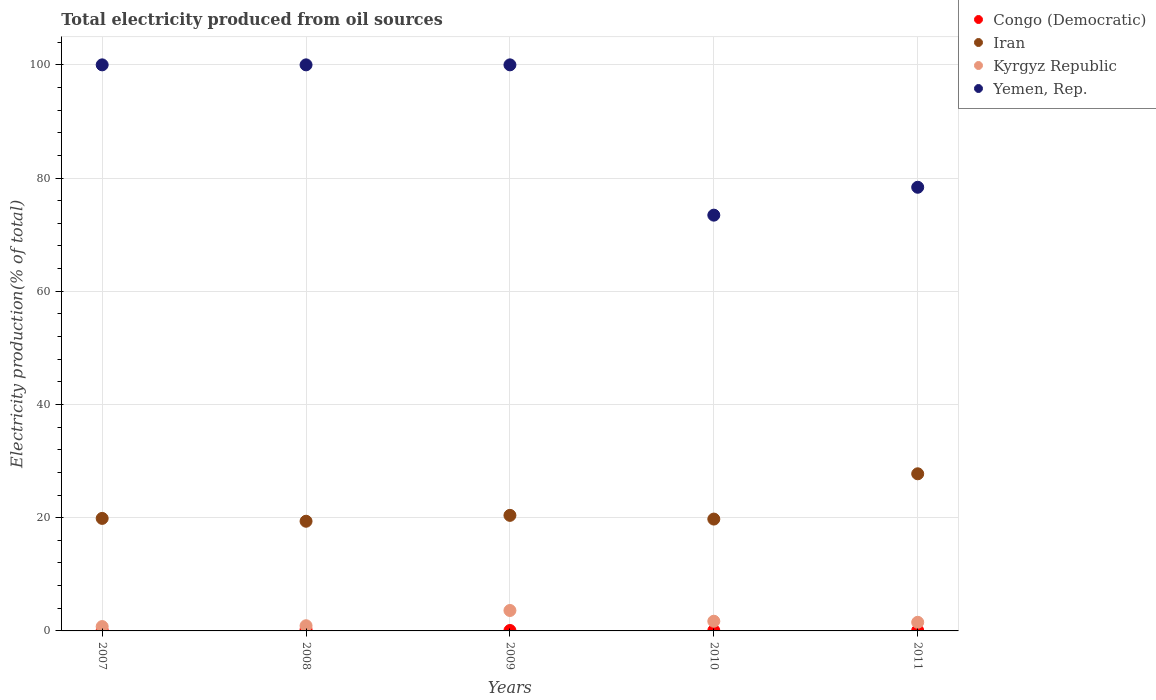Is the number of dotlines equal to the number of legend labels?
Provide a short and direct response. Yes. What is the total electricity produced in Yemen, Rep. in 2008?
Provide a short and direct response. 100. Across all years, what is the maximum total electricity produced in Yemen, Rep.?
Provide a short and direct response. 100. Across all years, what is the minimum total electricity produced in Kyrgyz Republic?
Provide a succinct answer. 0.77. What is the total total electricity produced in Iran in the graph?
Your answer should be very brief. 107.18. What is the difference between the total electricity produced in Yemen, Rep. in 2008 and that in 2011?
Offer a very short reply. 21.62. What is the difference between the total electricity produced in Kyrgyz Republic in 2007 and the total electricity produced in Iran in 2010?
Make the answer very short. -18.99. What is the average total electricity produced in Congo (Democratic) per year?
Give a very brief answer. 0.11. In the year 2011, what is the difference between the total electricity produced in Kyrgyz Republic and total electricity produced in Congo (Democratic)?
Ensure brevity in your answer.  1.45. What is the ratio of the total electricity produced in Yemen, Rep. in 2008 to that in 2010?
Keep it short and to the point. 1.36. What is the difference between the highest and the second highest total electricity produced in Kyrgyz Republic?
Provide a short and direct response. 1.9. What is the difference between the highest and the lowest total electricity produced in Kyrgyz Republic?
Offer a terse response. 2.84. Is the sum of the total electricity produced in Congo (Democratic) in 2008 and 2011 greater than the maximum total electricity produced in Iran across all years?
Your response must be concise. No. Is it the case that in every year, the sum of the total electricity produced in Kyrgyz Republic and total electricity produced in Congo (Democratic)  is greater than the sum of total electricity produced in Iran and total electricity produced in Yemen, Rep.?
Offer a terse response. Yes. Is it the case that in every year, the sum of the total electricity produced in Kyrgyz Republic and total electricity produced in Yemen, Rep.  is greater than the total electricity produced in Congo (Democratic)?
Make the answer very short. Yes. Does the total electricity produced in Iran monotonically increase over the years?
Make the answer very short. No. Is the total electricity produced in Yemen, Rep. strictly greater than the total electricity produced in Kyrgyz Republic over the years?
Ensure brevity in your answer.  Yes. Is the total electricity produced in Yemen, Rep. strictly less than the total electricity produced in Iran over the years?
Provide a short and direct response. No. How many dotlines are there?
Offer a very short reply. 4. How many years are there in the graph?
Your answer should be compact. 5. Does the graph contain any zero values?
Provide a succinct answer. No. Does the graph contain grids?
Keep it short and to the point. Yes. How are the legend labels stacked?
Your answer should be compact. Vertical. What is the title of the graph?
Provide a short and direct response. Total electricity produced from oil sources. Does "Middle East & North Africa (developing only)" appear as one of the legend labels in the graph?
Provide a succinct answer. No. What is the label or title of the X-axis?
Offer a terse response. Years. What is the Electricity production(% of total) of Congo (Democratic) in 2007?
Ensure brevity in your answer.  0.09. What is the Electricity production(% of total) in Iran in 2007?
Provide a short and direct response. 19.88. What is the Electricity production(% of total) in Kyrgyz Republic in 2007?
Your answer should be compact. 0.77. What is the Electricity production(% of total) in Congo (Democratic) in 2008?
Your answer should be very brief. 0.23. What is the Electricity production(% of total) of Iran in 2008?
Your answer should be very brief. 19.37. What is the Electricity production(% of total) of Kyrgyz Republic in 2008?
Your answer should be compact. 0.92. What is the Electricity production(% of total) in Congo (Democratic) in 2009?
Provide a short and direct response. 0.08. What is the Electricity production(% of total) of Iran in 2009?
Provide a succinct answer. 20.41. What is the Electricity production(% of total) in Kyrgyz Republic in 2009?
Your response must be concise. 3.61. What is the Electricity production(% of total) in Yemen, Rep. in 2009?
Your response must be concise. 100. What is the Electricity production(% of total) in Congo (Democratic) in 2010?
Make the answer very short. 0.08. What is the Electricity production(% of total) in Iran in 2010?
Offer a very short reply. 19.76. What is the Electricity production(% of total) of Kyrgyz Republic in 2010?
Your answer should be compact. 1.71. What is the Electricity production(% of total) of Yemen, Rep. in 2010?
Make the answer very short. 73.45. What is the Electricity production(% of total) of Congo (Democratic) in 2011?
Your answer should be very brief. 0.08. What is the Electricity production(% of total) of Iran in 2011?
Provide a short and direct response. 27.76. What is the Electricity production(% of total) of Kyrgyz Republic in 2011?
Provide a short and direct response. 1.52. What is the Electricity production(% of total) of Yemen, Rep. in 2011?
Offer a very short reply. 78.38. Across all years, what is the maximum Electricity production(% of total) in Congo (Democratic)?
Give a very brief answer. 0.23. Across all years, what is the maximum Electricity production(% of total) in Iran?
Keep it short and to the point. 27.76. Across all years, what is the maximum Electricity production(% of total) of Kyrgyz Republic?
Offer a terse response. 3.61. Across all years, what is the minimum Electricity production(% of total) in Congo (Democratic)?
Give a very brief answer. 0.08. Across all years, what is the minimum Electricity production(% of total) in Iran?
Provide a succinct answer. 19.37. Across all years, what is the minimum Electricity production(% of total) of Kyrgyz Republic?
Your answer should be compact. 0.77. Across all years, what is the minimum Electricity production(% of total) in Yemen, Rep.?
Make the answer very short. 73.45. What is the total Electricity production(% of total) in Congo (Democratic) in the graph?
Your answer should be compact. 0.54. What is the total Electricity production(% of total) of Iran in the graph?
Give a very brief answer. 107.18. What is the total Electricity production(% of total) of Kyrgyz Republic in the graph?
Ensure brevity in your answer.  8.53. What is the total Electricity production(% of total) in Yemen, Rep. in the graph?
Your response must be concise. 451.83. What is the difference between the Electricity production(% of total) in Congo (Democratic) in 2007 and that in 2008?
Ensure brevity in your answer.  -0.14. What is the difference between the Electricity production(% of total) in Iran in 2007 and that in 2008?
Offer a very short reply. 0.5. What is the difference between the Electricity production(% of total) of Kyrgyz Republic in 2007 and that in 2008?
Your response must be concise. -0.15. What is the difference between the Electricity production(% of total) of Congo (Democratic) in 2007 and that in 2009?
Provide a succinct answer. 0.01. What is the difference between the Electricity production(% of total) of Iran in 2007 and that in 2009?
Offer a terse response. -0.54. What is the difference between the Electricity production(% of total) in Kyrgyz Republic in 2007 and that in 2009?
Provide a short and direct response. -2.84. What is the difference between the Electricity production(% of total) in Congo (Democratic) in 2007 and that in 2010?
Your answer should be very brief. 0.01. What is the difference between the Electricity production(% of total) in Iran in 2007 and that in 2010?
Offer a very short reply. 0.12. What is the difference between the Electricity production(% of total) in Kyrgyz Republic in 2007 and that in 2010?
Give a very brief answer. -0.94. What is the difference between the Electricity production(% of total) of Yemen, Rep. in 2007 and that in 2010?
Your response must be concise. 26.55. What is the difference between the Electricity production(% of total) of Congo (Democratic) in 2007 and that in 2011?
Ensure brevity in your answer.  0.01. What is the difference between the Electricity production(% of total) of Iran in 2007 and that in 2011?
Make the answer very short. -7.88. What is the difference between the Electricity production(% of total) of Kyrgyz Republic in 2007 and that in 2011?
Keep it short and to the point. -0.76. What is the difference between the Electricity production(% of total) of Yemen, Rep. in 2007 and that in 2011?
Give a very brief answer. 21.62. What is the difference between the Electricity production(% of total) in Congo (Democratic) in 2008 and that in 2009?
Keep it short and to the point. 0.15. What is the difference between the Electricity production(% of total) of Iran in 2008 and that in 2009?
Give a very brief answer. -1.04. What is the difference between the Electricity production(% of total) of Kyrgyz Republic in 2008 and that in 2009?
Provide a succinct answer. -2.69. What is the difference between the Electricity production(% of total) in Congo (Democratic) in 2008 and that in 2010?
Your answer should be compact. 0.15. What is the difference between the Electricity production(% of total) of Iran in 2008 and that in 2010?
Offer a very short reply. -0.38. What is the difference between the Electricity production(% of total) of Kyrgyz Republic in 2008 and that in 2010?
Offer a terse response. -0.79. What is the difference between the Electricity production(% of total) of Yemen, Rep. in 2008 and that in 2010?
Make the answer very short. 26.55. What is the difference between the Electricity production(% of total) in Congo (Democratic) in 2008 and that in 2011?
Ensure brevity in your answer.  0.15. What is the difference between the Electricity production(% of total) in Iran in 2008 and that in 2011?
Provide a short and direct response. -8.38. What is the difference between the Electricity production(% of total) of Kyrgyz Republic in 2008 and that in 2011?
Your answer should be compact. -0.61. What is the difference between the Electricity production(% of total) of Yemen, Rep. in 2008 and that in 2011?
Give a very brief answer. 21.62. What is the difference between the Electricity production(% of total) of Iran in 2009 and that in 2010?
Offer a very short reply. 0.66. What is the difference between the Electricity production(% of total) of Kyrgyz Republic in 2009 and that in 2010?
Make the answer very short. 1.9. What is the difference between the Electricity production(% of total) of Yemen, Rep. in 2009 and that in 2010?
Give a very brief answer. 26.55. What is the difference between the Electricity production(% of total) in Iran in 2009 and that in 2011?
Give a very brief answer. -7.34. What is the difference between the Electricity production(% of total) in Kyrgyz Republic in 2009 and that in 2011?
Your answer should be compact. 2.09. What is the difference between the Electricity production(% of total) of Yemen, Rep. in 2009 and that in 2011?
Your response must be concise. 21.62. What is the difference between the Electricity production(% of total) in Congo (Democratic) in 2010 and that in 2011?
Provide a succinct answer. -0. What is the difference between the Electricity production(% of total) of Iran in 2010 and that in 2011?
Your answer should be compact. -8. What is the difference between the Electricity production(% of total) in Kyrgyz Republic in 2010 and that in 2011?
Make the answer very short. 0.19. What is the difference between the Electricity production(% of total) in Yemen, Rep. in 2010 and that in 2011?
Offer a very short reply. -4.93. What is the difference between the Electricity production(% of total) in Congo (Democratic) in 2007 and the Electricity production(% of total) in Iran in 2008?
Make the answer very short. -19.29. What is the difference between the Electricity production(% of total) in Congo (Democratic) in 2007 and the Electricity production(% of total) in Kyrgyz Republic in 2008?
Make the answer very short. -0.83. What is the difference between the Electricity production(% of total) of Congo (Democratic) in 2007 and the Electricity production(% of total) of Yemen, Rep. in 2008?
Ensure brevity in your answer.  -99.91. What is the difference between the Electricity production(% of total) in Iran in 2007 and the Electricity production(% of total) in Kyrgyz Republic in 2008?
Your response must be concise. 18.96. What is the difference between the Electricity production(% of total) in Iran in 2007 and the Electricity production(% of total) in Yemen, Rep. in 2008?
Ensure brevity in your answer.  -80.12. What is the difference between the Electricity production(% of total) of Kyrgyz Republic in 2007 and the Electricity production(% of total) of Yemen, Rep. in 2008?
Your answer should be compact. -99.23. What is the difference between the Electricity production(% of total) of Congo (Democratic) in 2007 and the Electricity production(% of total) of Iran in 2009?
Provide a short and direct response. -20.33. What is the difference between the Electricity production(% of total) of Congo (Democratic) in 2007 and the Electricity production(% of total) of Kyrgyz Republic in 2009?
Your answer should be compact. -3.52. What is the difference between the Electricity production(% of total) in Congo (Democratic) in 2007 and the Electricity production(% of total) in Yemen, Rep. in 2009?
Your answer should be compact. -99.91. What is the difference between the Electricity production(% of total) of Iran in 2007 and the Electricity production(% of total) of Kyrgyz Republic in 2009?
Provide a short and direct response. 16.27. What is the difference between the Electricity production(% of total) of Iran in 2007 and the Electricity production(% of total) of Yemen, Rep. in 2009?
Provide a succinct answer. -80.12. What is the difference between the Electricity production(% of total) in Kyrgyz Republic in 2007 and the Electricity production(% of total) in Yemen, Rep. in 2009?
Ensure brevity in your answer.  -99.23. What is the difference between the Electricity production(% of total) of Congo (Democratic) in 2007 and the Electricity production(% of total) of Iran in 2010?
Your answer should be compact. -19.67. What is the difference between the Electricity production(% of total) of Congo (Democratic) in 2007 and the Electricity production(% of total) of Kyrgyz Republic in 2010?
Ensure brevity in your answer.  -1.62. What is the difference between the Electricity production(% of total) in Congo (Democratic) in 2007 and the Electricity production(% of total) in Yemen, Rep. in 2010?
Your answer should be very brief. -73.36. What is the difference between the Electricity production(% of total) of Iran in 2007 and the Electricity production(% of total) of Kyrgyz Republic in 2010?
Provide a short and direct response. 18.17. What is the difference between the Electricity production(% of total) of Iran in 2007 and the Electricity production(% of total) of Yemen, Rep. in 2010?
Offer a terse response. -53.57. What is the difference between the Electricity production(% of total) of Kyrgyz Republic in 2007 and the Electricity production(% of total) of Yemen, Rep. in 2010?
Give a very brief answer. -72.68. What is the difference between the Electricity production(% of total) in Congo (Democratic) in 2007 and the Electricity production(% of total) in Iran in 2011?
Make the answer very short. -27.67. What is the difference between the Electricity production(% of total) of Congo (Democratic) in 2007 and the Electricity production(% of total) of Kyrgyz Republic in 2011?
Offer a terse response. -1.43. What is the difference between the Electricity production(% of total) of Congo (Democratic) in 2007 and the Electricity production(% of total) of Yemen, Rep. in 2011?
Your answer should be very brief. -78.29. What is the difference between the Electricity production(% of total) of Iran in 2007 and the Electricity production(% of total) of Kyrgyz Republic in 2011?
Offer a very short reply. 18.35. What is the difference between the Electricity production(% of total) in Iran in 2007 and the Electricity production(% of total) in Yemen, Rep. in 2011?
Provide a short and direct response. -58.5. What is the difference between the Electricity production(% of total) in Kyrgyz Republic in 2007 and the Electricity production(% of total) in Yemen, Rep. in 2011?
Provide a succinct answer. -77.61. What is the difference between the Electricity production(% of total) of Congo (Democratic) in 2008 and the Electricity production(% of total) of Iran in 2009?
Provide a succinct answer. -20.19. What is the difference between the Electricity production(% of total) in Congo (Democratic) in 2008 and the Electricity production(% of total) in Kyrgyz Republic in 2009?
Provide a succinct answer. -3.38. What is the difference between the Electricity production(% of total) in Congo (Democratic) in 2008 and the Electricity production(% of total) in Yemen, Rep. in 2009?
Offer a terse response. -99.77. What is the difference between the Electricity production(% of total) in Iran in 2008 and the Electricity production(% of total) in Kyrgyz Republic in 2009?
Provide a succinct answer. 15.77. What is the difference between the Electricity production(% of total) in Iran in 2008 and the Electricity production(% of total) in Yemen, Rep. in 2009?
Your answer should be very brief. -80.63. What is the difference between the Electricity production(% of total) of Kyrgyz Republic in 2008 and the Electricity production(% of total) of Yemen, Rep. in 2009?
Provide a succinct answer. -99.08. What is the difference between the Electricity production(% of total) in Congo (Democratic) in 2008 and the Electricity production(% of total) in Iran in 2010?
Your response must be concise. -19.53. What is the difference between the Electricity production(% of total) in Congo (Democratic) in 2008 and the Electricity production(% of total) in Kyrgyz Republic in 2010?
Offer a terse response. -1.49. What is the difference between the Electricity production(% of total) in Congo (Democratic) in 2008 and the Electricity production(% of total) in Yemen, Rep. in 2010?
Ensure brevity in your answer.  -73.22. What is the difference between the Electricity production(% of total) of Iran in 2008 and the Electricity production(% of total) of Kyrgyz Republic in 2010?
Your answer should be very brief. 17.66. What is the difference between the Electricity production(% of total) of Iran in 2008 and the Electricity production(% of total) of Yemen, Rep. in 2010?
Make the answer very short. -54.07. What is the difference between the Electricity production(% of total) in Kyrgyz Republic in 2008 and the Electricity production(% of total) in Yemen, Rep. in 2010?
Give a very brief answer. -72.53. What is the difference between the Electricity production(% of total) in Congo (Democratic) in 2008 and the Electricity production(% of total) in Iran in 2011?
Keep it short and to the point. -27.53. What is the difference between the Electricity production(% of total) in Congo (Democratic) in 2008 and the Electricity production(% of total) in Kyrgyz Republic in 2011?
Offer a terse response. -1.3. What is the difference between the Electricity production(% of total) of Congo (Democratic) in 2008 and the Electricity production(% of total) of Yemen, Rep. in 2011?
Provide a short and direct response. -78.15. What is the difference between the Electricity production(% of total) in Iran in 2008 and the Electricity production(% of total) in Kyrgyz Republic in 2011?
Ensure brevity in your answer.  17.85. What is the difference between the Electricity production(% of total) of Iran in 2008 and the Electricity production(% of total) of Yemen, Rep. in 2011?
Ensure brevity in your answer.  -59. What is the difference between the Electricity production(% of total) of Kyrgyz Republic in 2008 and the Electricity production(% of total) of Yemen, Rep. in 2011?
Give a very brief answer. -77.46. What is the difference between the Electricity production(% of total) in Congo (Democratic) in 2009 and the Electricity production(% of total) in Iran in 2010?
Your answer should be very brief. -19.68. What is the difference between the Electricity production(% of total) in Congo (Democratic) in 2009 and the Electricity production(% of total) in Kyrgyz Republic in 2010?
Your answer should be compact. -1.63. What is the difference between the Electricity production(% of total) in Congo (Democratic) in 2009 and the Electricity production(% of total) in Yemen, Rep. in 2010?
Your answer should be compact. -73.37. What is the difference between the Electricity production(% of total) in Iran in 2009 and the Electricity production(% of total) in Kyrgyz Republic in 2010?
Keep it short and to the point. 18.7. What is the difference between the Electricity production(% of total) in Iran in 2009 and the Electricity production(% of total) in Yemen, Rep. in 2010?
Your response must be concise. -53.04. What is the difference between the Electricity production(% of total) in Kyrgyz Republic in 2009 and the Electricity production(% of total) in Yemen, Rep. in 2010?
Your answer should be very brief. -69.84. What is the difference between the Electricity production(% of total) in Congo (Democratic) in 2009 and the Electricity production(% of total) in Iran in 2011?
Provide a succinct answer. -27.68. What is the difference between the Electricity production(% of total) of Congo (Democratic) in 2009 and the Electricity production(% of total) of Kyrgyz Republic in 2011?
Provide a succinct answer. -1.45. What is the difference between the Electricity production(% of total) of Congo (Democratic) in 2009 and the Electricity production(% of total) of Yemen, Rep. in 2011?
Provide a succinct answer. -78.3. What is the difference between the Electricity production(% of total) of Iran in 2009 and the Electricity production(% of total) of Kyrgyz Republic in 2011?
Provide a short and direct response. 18.89. What is the difference between the Electricity production(% of total) of Iran in 2009 and the Electricity production(% of total) of Yemen, Rep. in 2011?
Make the answer very short. -57.96. What is the difference between the Electricity production(% of total) of Kyrgyz Republic in 2009 and the Electricity production(% of total) of Yemen, Rep. in 2011?
Your answer should be compact. -74.77. What is the difference between the Electricity production(% of total) of Congo (Democratic) in 2010 and the Electricity production(% of total) of Iran in 2011?
Keep it short and to the point. -27.68. What is the difference between the Electricity production(% of total) in Congo (Democratic) in 2010 and the Electricity production(% of total) in Kyrgyz Republic in 2011?
Make the answer very short. -1.45. What is the difference between the Electricity production(% of total) of Congo (Democratic) in 2010 and the Electricity production(% of total) of Yemen, Rep. in 2011?
Your answer should be very brief. -78.3. What is the difference between the Electricity production(% of total) in Iran in 2010 and the Electricity production(% of total) in Kyrgyz Republic in 2011?
Offer a very short reply. 18.23. What is the difference between the Electricity production(% of total) of Iran in 2010 and the Electricity production(% of total) of Yemen, Rep. in 2011?
Provide a succinct answer. -58.62. What is the difference between the Electricity production(% of total) in Kyrgyz Republic in 2010 and the Electricity production(% of total) in Yemen, Rep. in 2011?
Your answer should be very brief. -76.67. What is the average Electricity production(% of total) of Congo (Democratic) per year?
Give a very brief answer. 0.11. What is the average Electricity production(% of total) of Iran per year?
Your response must be concise. 21.44. What is the average Electricity production(% of total) in Kyrgyz Republic per year?
Offer a terse response. 1.71. What is the average Electricity production(% of total) of Yemen, Rep. per year?
Provide a succinct answer. 90.36. In the year 2007, what is the difference between the Electricity production(% of total) in Congo (Democratic) and Electricity production(% of total) in Iran?
Provide a short and direct response. -19.79. In the year 2007, what is the difference between the Electricity production(% of total) in Congo (Democratic) and Electricity production(% of total) in Kyrgyz Republic?
Give a very brief answer. -0.68. In the year 2007, what is the difference between the Electricity production(% of total) in Congo (Democratic) and Electricity production(% of total) in Yemen, Rep.?
Provide a succinct answer. -99.91. In the year 2007, what is the difference between the Electricity production(% of total) of Iran and Electricity production(% of total) of Kyrgyz Republic?
Keep it short and to the point. 19.11. In the year 2007, what is the difference between the Electricity production(% of total) of Iran and Electricity production(% of total) of Yemen, Rep.?
Provide a short and direct response. -80.12. In the year 2007, what is the difference between the Electricity production(% of total) of Kyrgyz Republic and Electricity production(% of total) of Yemen, Rep.?
Give a very brief answer. -99.23. In the year 2008, what is the difference between the Electricity production(% of total) of Congo (Democratic) and Electricity production(% of total) of Iran?
Make the answer very short. -19.15. In the year 2008, what is the difference between the Electricity production(% of total) in Congo (Democratic) and Electricity production(% of total) in Kyrgyz Republic?
Provide a succinct answer. -0.69. In the year 2008, what is the difference between the Electricity production(% of total) of Congo (Democratic) and Electricity production(% of total) of Yemen, Rep.?
Give a very brief answer. -99.77. In the year 2008, what is the difference between the Electricity production(% of total) of Iran and Electricity production(% of total) of Kyrgyz Republic?
Your answer should be very brief. 18.46. In the year 2008, what is the difference between the Electricity production(% of total) of Iran and Electricity production(% of total) of Yemen, Rep.?
Your answer should be very brief. -80.63. In the year 2008, what is the difference between the Electricity production(% of total) of Kyrgyz Republic and Electricity production(% of total) of Yemen, Rep.?
Your answer should be compact. -99.08. In the year 2009, what is the difference between the Electricity production(% of total) of Congo (Democratic) and Electricity production(% of total) of Iran?
Offer a very short reply. -20.34. In the year 2009, what is the difference between the Electricity production(% of total) in Congo (Democratic) and Electricity production(% of total) in Kyrgyz Republic?
Provide a short and direct response. -3.53. In the year 2009, what is the difference between the Electricity production(% of total) of Congo (Democratic) and Electricity production(% of total) of Yemen, Rep.?
Your response must be concise. -99.92. In the year 2009, what is the difference between the Electricity production(% of total) in Iran and Electricity production(% of total) in Kyrgyz Republic?
Keep it short and to the point. 16.81. In the year 2009, what is the difference between the Electricity production(% of total) in Iran and Electricity production(% of total) in Yemen, Rep.?
Your answer should be very brief. -79.59. In the year 2009, what is the difference between the Electricity production(% of total) in Kyrgyz Republic and Electricity production(% of total) in Yemen, Rep.?
Provide a short and direct response. -96.39. In the year 2010, what is the difference between the Electricity production(% of total) of Congo (Democratic) and Electricity production(% of total) of Iran?
Your answer should be compact. -19.68. In the year 2010, what is the difference between the Electricity production(% of total) in Congo (Democratic) and Electricity production(% of total) in Kyrgyz Republic?
Provide a short and direct response. -1.63. In the year 2010, what is the difference between the Electricity production(% of total) of Congo (Democratic) and Electricity production(% of total) of Yemen, Rep.?
Offer a very short reply. -73.37. In the year 2010, what is the difference between the Electricity production(% of total) in Iran and Electricity production(% of total) in Kyrgyz Republic?
Ensure brevity in your answer.  18.05. In the year 2010, what is the difference between the Electricity production(% of total) in Iran and Electricity production(% of total) in Yemen, Rep.?
Provide a succinct answer. -53.69. In the year 2010, what is the difference between the Electricity production(% of total) in Kyrgyz Republic and Electricity production(% of total) in Yemen, Rep.?
Your answer should be very brief. -71.74. In the year 2011, what is the difference between the Electricity production(% of total) of Congo (Democratic) and Electricity production(% of total) of Iran?
Your answer should be compact. -27.68. In the year 2011, what is the difference between the Electricity production(% of total) of Congo (Democratic) and Electricity production(% of total) of Kyrgyz Republic?
Keep it short and to the point. -1.45. In the year 2011, what is the difference between the Electricity production(% of total) in Congo (Democratic) and Electricity production(% of total) in Yemen, Rep.?
Provide a short and direct response. -78.3. In the year 2011, what is the difference between the Electricity production(% of total) in Iran and Electricity production(% of total) in Kyrgyz Republic?
Offer a very short reply. 26.23. In the year 2011, what is the difference between the Electricity production(% of total) of Iran and Electricity production(% of total) of Yemen, Rep.?
Your response must be concise. -50.62. In the year 2011, what is the difference between the Electricity production(% of total) of Kyrgyz Republic and Electricity production(% of total) of Yemen, Rep.?
Give a very brief answer. -76.85. What is the ratio of the Electricity production(% of total) in Congo (Democratic) in 2007 to that in 2008?
Give a very brief answer. 0.39. What is the ratio of the Electricity production(% of total) in Iran in 2007 to that in 2008?
Make the answer very short. 1.03. What is the ratio of the Electricity production(% of total) in Kyrgyz Republic in 2007 to that in 2008?
Offer a terse response. 0.84. What is the ratio of the Electricity production(% of total) of Yemen, Rep. in 2007 to that in 2008?
Make the answer very short. 1. What is the ratio of the Electricity production(% of total) in Congo (Democratic) in 2007 to that in 2009?
Your answer should be compact. 1.16. What is the ratio of the Electricity production(% of total) in Iran in 2007 to that in 2009?
Offer a terse response. 0.97. What is the ratio of the Electricity production(% of total) in Kyrgyz Republic in 2007 to that in 2009?
Provide a succinct answer. 0.21. What is the ratio of the Electricity production(% of total) of Congo (Democratic) in 2007 to that in 2010?
Make the answer very short. 1.17. What is the ratio of the Electricity production(% of total) in Iran in 2007 to that in 2010?
Ensure brevity in your answer.  1.01. What is the ratio of the Electricity production(% of total) in Kyrgyz Republic in 2007 to that in 2010?
Your answer should be very brief. 0.45. What is the ratio of the Electricity production(% of total) of Yemen, Rep. in 2007 to that in 2010?
Provide a short and direct response. 1.36. What is the ratio of the Electricity production(% of total) of Congo (Democratic) in 2007 to that in 2011?
Your answer should be very brief. 1.17. What is the ratio of the Electricity production(% of total) of Iran in 2007 to that in 2011?
Your answer should be very brief. 0.72. What is the ratio of the Electricity production(% of total) of Kyrgyz Republic in 2007 to that in 2011?
Keep it short and to the point. 0.5. What is the ratio of the Electricity production(% of total) of Yemen, Rep. in 2007 to that in 2011?
Your answer should be very brief. 1.28. What is the ratio of the Electricity production(% of total) in Congo (Democratic) in 2008 to that in 2009?
Make the answer very short. 2.95. What is the ratio of the Electricity production(% of total) of Iran in 2008 to that in 2009?
Give a very brief answer. 0.95. What is the ratio of the Electricity production(% of total) of Kyrgyz Republic in 2008 to that in 2009?
Your response must be concise. 0.25. What is the ratio of the Electricity production(% of total) in Yemen, Rep. in 2008 to that in 2009?
Your answer should be very brief. 1. What is the ratio of the Electricity production(% of total) of Congo (Democratic) in 2008 to that in 2010?
Make the answer very short. 2.97. What is the ratio of the Electricity production(% of total) in Iran in 2008 to that in 2010?
Offer a very short reply. 0.98. What is the ratio of the Electricity production(% of total) in Kyrgyz Republic in 2008 to that in 2010?
Give a very brief answer. 0.54. What is the ratio of the Electricity production(% of total) of Yemen, Rep. in 2008 to that in 2010?
Offer a terse response. 1.36. What is the ratio of the Electricity production(% of total) of Congo (Democratic) in 2008 to that in 2011?
Ensure brevity in your answer.  2.97. What is the ratio of the Electricity production(% of total) in Iran in 2008 to that in 2011?
Give a very brief answer. 0.7. What is the ratio of the Electricity production(% of total) in Kyrgyz Republic in 2008 to that in 2011?
Make the answer very short. 0.6. What is the ratio of the Electricity production(% of total) in Yemen, Rep. in 2008 to that in 2011?
Offer a very short reply. 1.28. What is the ratio of the Electricity production(% of total) of Congo (Democratic) in 2009 to that in 2010?
Give a very brief answer. 1.01. What is the ratio of the Electricity production(% of total) in Iran in 2009 to that in 2010?
Give a very brief answer. 1.03. What is the ratio of the Electricity production(% of total) in Kyrgyz Republic in 2009 to that in 2010?
Ensure brevity in your answer.  2.11. What is the ratio of the Electricity production(% of total) in Yemen, Rep. in 2009 to that in 2010?
Your answer should be compact. 1.36. What is the ratio of the Electricity production(% of total) of Iran in 2009 to that in 2011?
Offer a very short reply. 0.74. What is the ratio of the Electricity production(% of total) in Kyrgyz Republic in 2009 to that in 2011?
Provide a short and direct response. 2.37. What is the ratio of the Electricity production(% of total) of Yemen, Rep. in 2009 to that in 2011?
Ensure brevity in your answer.  1.28. What is the ratio of the Electricity production(% of total) of Iran in 2010 to that in 2011?
Keep it short and to the point. 0.71. What is the ratio of the Electricity production(% of total) in Kyrgyz Republic in 2010 to that in 2011?
Your response must be concise. 1.12. What is the ratio of the Electricity production(% of total) of Yemen, Rep. in 2010 to that in 2011?
Make the answer very short. 0.94. What is the difference between the highest and the second highest Electricity production(% of total) in Congo (Democratic)?
Your answer should be very brief. 0.14. What is the difference between the highest and the second highest Electricity production(% of total) in Iran?
Your response must be concise. 7.34. What is the difference between the highest and the second highest Electricity production(% of total) in Kyrgyz Republic?
Keep it short and to the point. 1.9. What is the difference between the highest and the second highest Electricity production(% of total) in Yemen, Rep.?
Offer a terse response. 0. What is the difference between the highest and the lowest Electricity production(% of total) of Congo (Democratic)?
Your response must be concise. 0.15. What is the difference between the highest and the lowest Electricity production(% of total) of Iran?
Provide a succinct answer. 8.38. What is the difference between the highest and the lowest Electricity production(% of total) of Kyrgyz Republic?
Make the answer very short. 2.84. What is the difference between the highest and the lowest Electricity production(% of total) of Yemen, Rep.?
Provide a succinct answer. 26.55. 